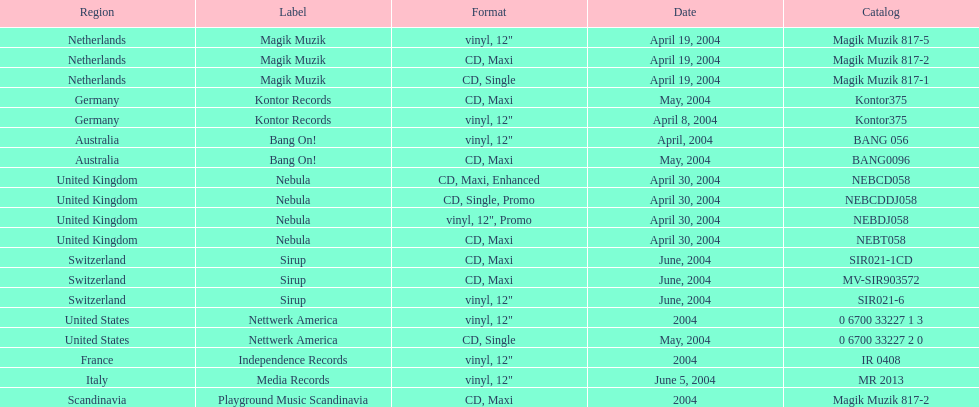What region is above australia? Germany. 